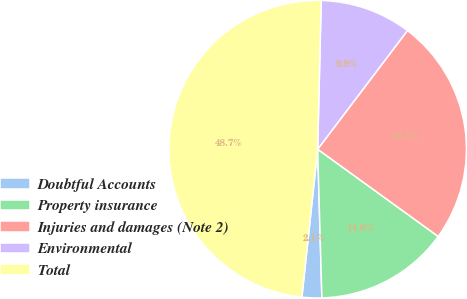Convert chart to OTSL. <chart><loc_0><loc_0><loc_500><loc_500><pie_chart><fcel>Doubtful Accounts<fcel>Property insurance<fcel>Injuries and damages (Note 2)<fcel>Environmental<fcel>Total<nl><fcel>2.14%<fcel>14.58%<fcel>24.66%<fcel>9.93%<fcel>48.69%<nl></chart> 